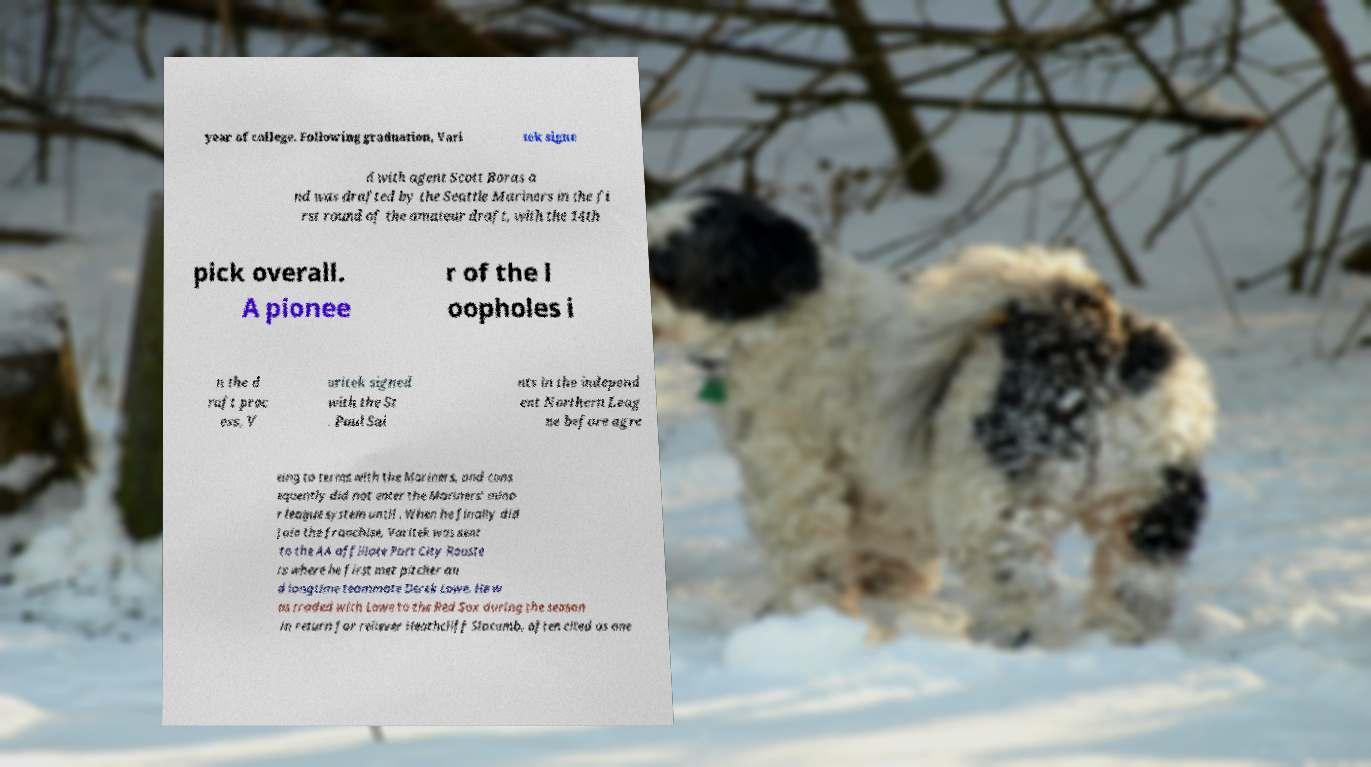Could you assist in decoding the text presented in this image and type it out clearly? year of college. Following graduation, Vari tek signe d with agent Scott Boras a nd was drafted by the Seattle Mariners in the fi rst round of the amateur draft, with the 14th pick overall. A pionee r of the l oopholes i n the d raft proc ess, V aritek signed with the St . Paul Sai nts in the independ ent Northern Leag ue before agre eing to terms with the Mariners, and cons equently did not enter the Mariners' mino r league system until . When he finally did join the franchise, Varitek was sent to the AA affiliate Port City Rooste rs where he first met pitcher an d longtime teammate Derek Lowe. He w as traded with Lowe to the Red Sox during the season in return for reliever Heathcliff Slocumb, often cited as one 